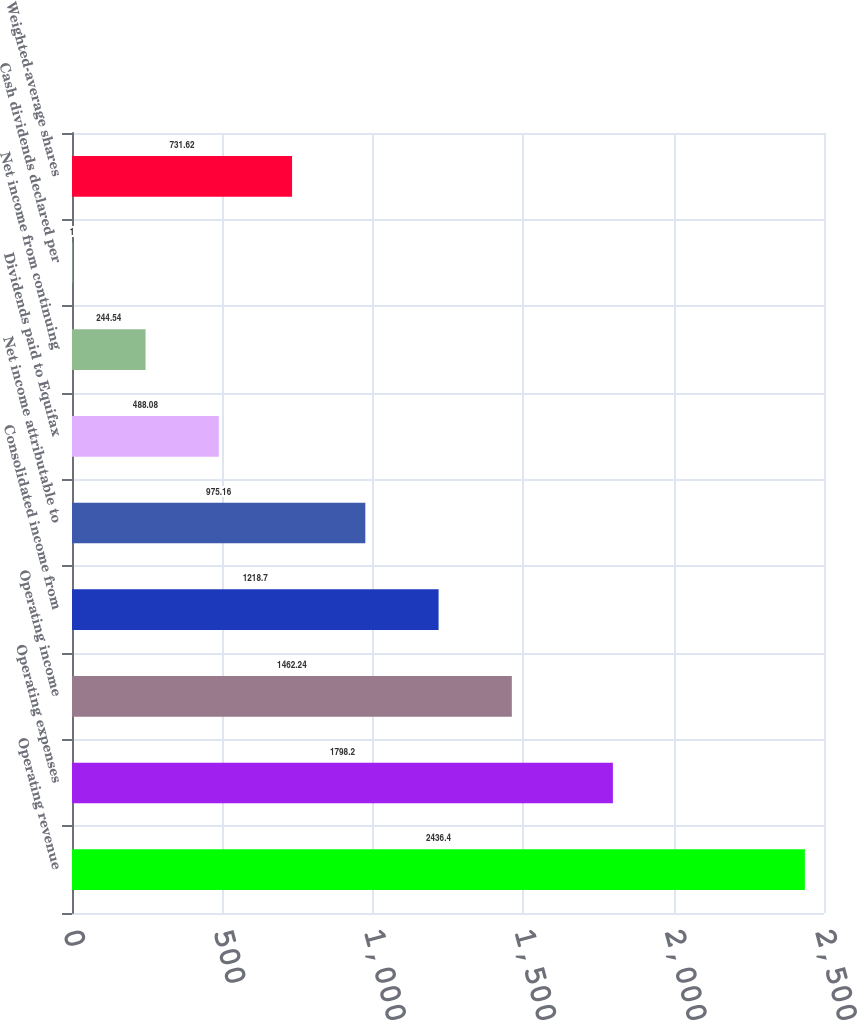<chart> <loc_0><loc_0><loc_500><loc_500><bar_chart><fcel>Operating revenue<fcel>Operating expenses<fcel>Operating income<fcel>Consolidated income from<fcel>Net income attributable to<fcel>Dividends paid to Equifax<fcel>Net income from continuing<fcel>Cash dividends declared per<fcel>Weighted-average shares<nl><fcel>2436.4<fcel>1798.2<fcel>1462.24<fcel>1218.7<fcel>975.16<fcel>488.08<fcel>244.54<fcel>1<fcel>731.62<nl></chart> 